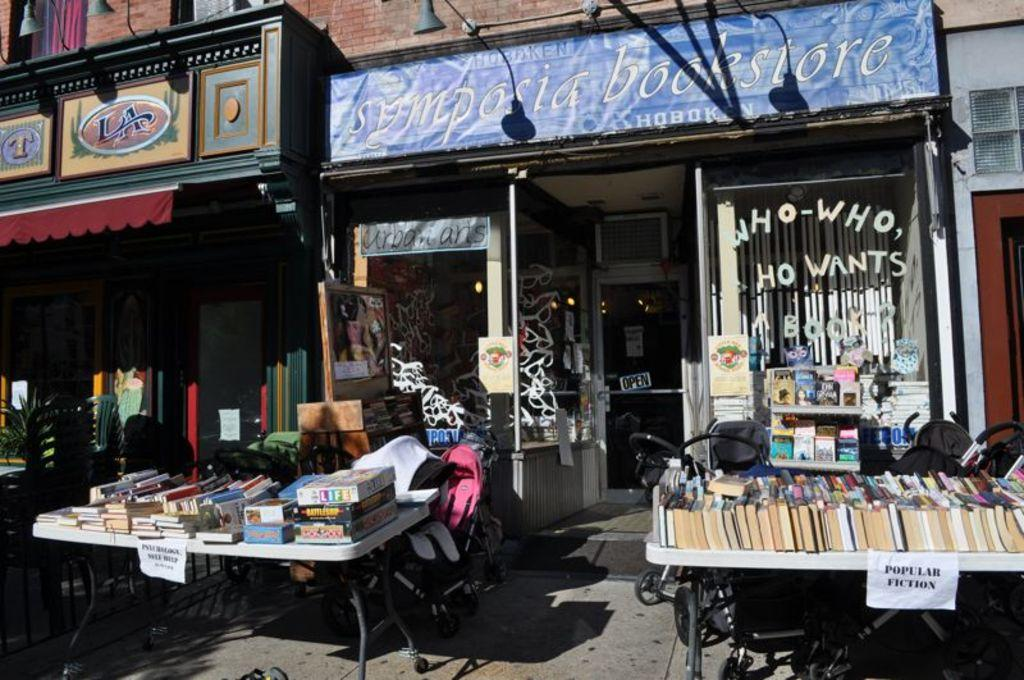What objects can be seen on the tables in the image? There are books and papers on the tables in the image. What type of furniture is present in the image? There are chairs in the image. What type of establishments can be seen in the image? There are shops in the image. What type of signage is present in the image? There are boards in the image. What type of illumination is present in the image? There are lights in the image. What other items can be seen in the image? There are other items present in the image, but their specific nature is not mentioned in the provided facts. What type of ink is used to write on the parcel in the image? There is no parcel present in the image, so it is not possible to determine what type of ink might be used. 